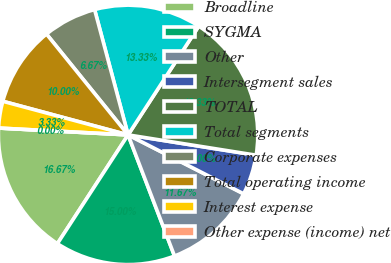Convert chart. <chart><loc_0><loc_0><loc_500><loc_500><pie_chart><fcel>Broadline<fcel>SYGMA<fcel>Other<fcel>Intersegment sales<fcel>TOTAL<fcel>Total segments<fcel>Corporate expenses<fcel>Total operating income<fcel>Interest expense<fcel>Other expense (income) net<nl><fcel>16.67%<fcel>15.0%<fcel>11.67%<fcel>5.0%<fcel>18.33%<fcel>13.33%<fcel>6.67%<fcel>10.0%<fcel>3.33%<fcel>0.0%<nl></chart> 